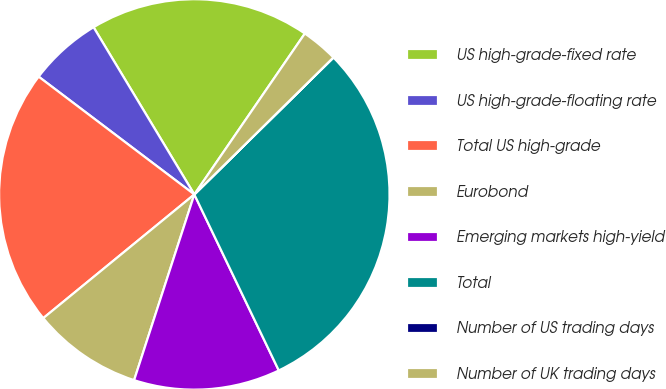Convert chart. <chart><loc_0><loc_0><loc_500><loc_500><pie_chart><fcel>US high-grade-fixed rate<fcel>US high-grade-floating rate<fcel>Total US high-grade<fcel>Eurobond<fcel>Emerging markets high-yield<fcel>Total<fcel>Number of US trading days<fcel>Number of UK trading days<nl><fcel>18.21%<fcel>6.06%<fcel>21.23%<fcel>9.09%<fcel>12.11%<fcel>30.25%<fcel>0.01%<fcel>3.04%<nl></chart> 